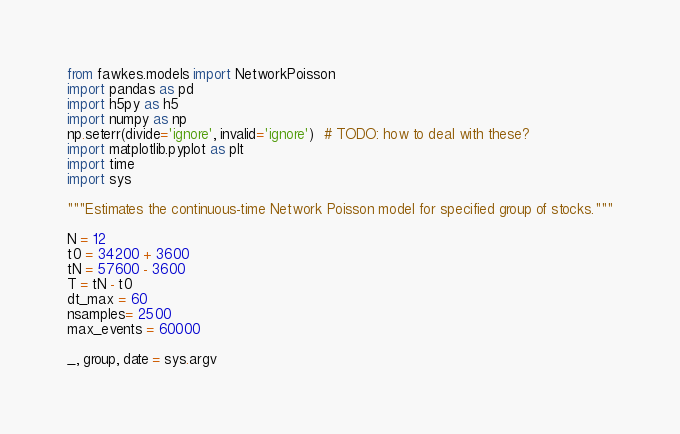<code> <loc_0><loc_0><loc_500><loc_500><_Python_>from fawkes.models import NetworkPoisson
import pandas as pd
import h5py as h5
import numpy as np
np.seterr(divide='ignore', invalid='ignore')  # TODO: how to deal with these?
import matplotlib.pyplot as plt
import time
import sys

"""Estimates the continuous-time Network Poisson model for specified group of stocks."""

N = 12
t0 = 34200 + 3600
tN = 57600 - 3600
T = tN - t0
dt_max = 60
nsamples= 2500
max_events = 60000

_, group, date = sys.argv</code> 